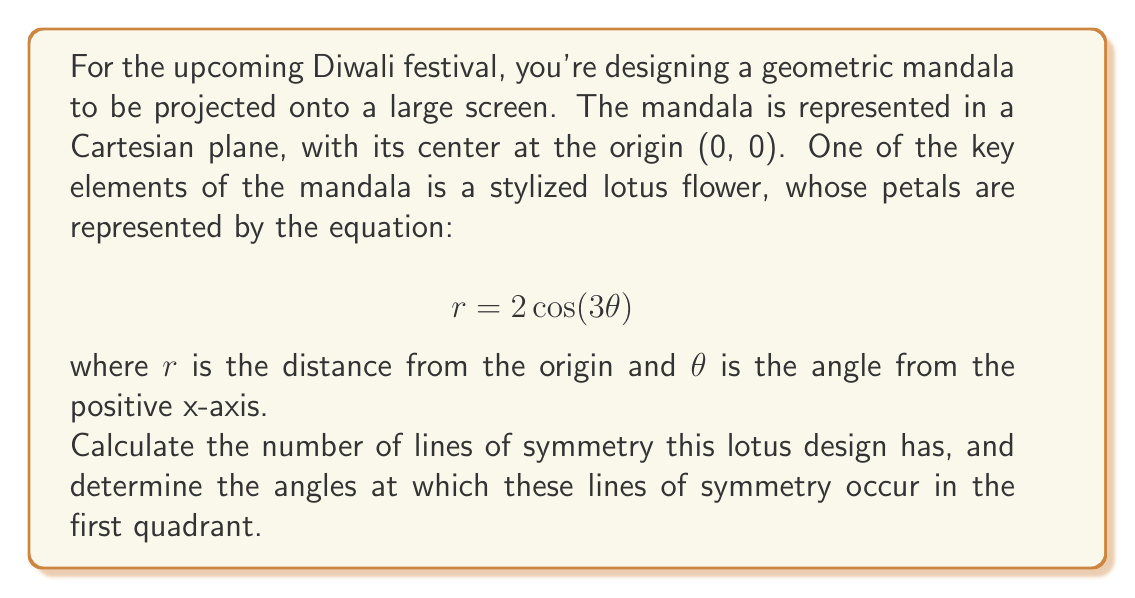What is the answer to this math problem? To solve this problem, we need to understand the properties of polar curves and their symmetry:

1) The general equation $r = a\cos(n\theta)$ or $r = a\sin(n\theta)$ produces a rose curve with $2n$ petals if $n$ is odd, or $n$ petals if $n$ is even.

2) In our case, $r = 2\cos(3\theta)$, so $n = 3$. Since 3 is odd, this curve will have $2n = 2(3) = 6$ petals.

3) The number of lines of symmetry in a rose curve is always equal to the number of petals.

4) Therefore, this lotus design has 6 lines of symmetry.

5) To find the angles of these lines of symmetry in the first quadrant:
   - The lines of symmetry occur at regular intervals of $\frac{\pi}{n} = \frac{\pi}{3}$ radians.
   - In the first quadrant (0 to $\frac{\pi}{2}$), we will have symmetry lines at:
     $0$, $\frac{\pi}{6}$, and $\frac{\pi}{3}$ radians.

6) Converting these to degrees:
   $0° = 0$ radians
   $30° = \frac{\pi}{6}$ radians
   $60° = \frac{\pi}{3}$ radians

[asy]
import graph;
size(200);

real r(real t) {return 2*cos(3*t);}
path roseCurve = polargraph(r, 0, 2pi, 500);

draw(roseCurve, blue);
draw((-2.5,0)--(2.5,0), gray);
draw((0,-2.5)--(0,2.5), gray);

for(int i=0; i<6; ++i) {
  draw((0,0)--2.5*dir(i*pi/3), red+dashed);
}

label("0°", (2.7,0), E);
label("30°", 2.7*dir(pi/6), NE);
label("60°", 2.7*dir(pi/3), NW);

dot((0,0), red);
[/asy]
Answer: The lotus design has 6 lines of symmetry. In the first quadrant, these lines occur at angles of 0°, 30°, and 60°. 